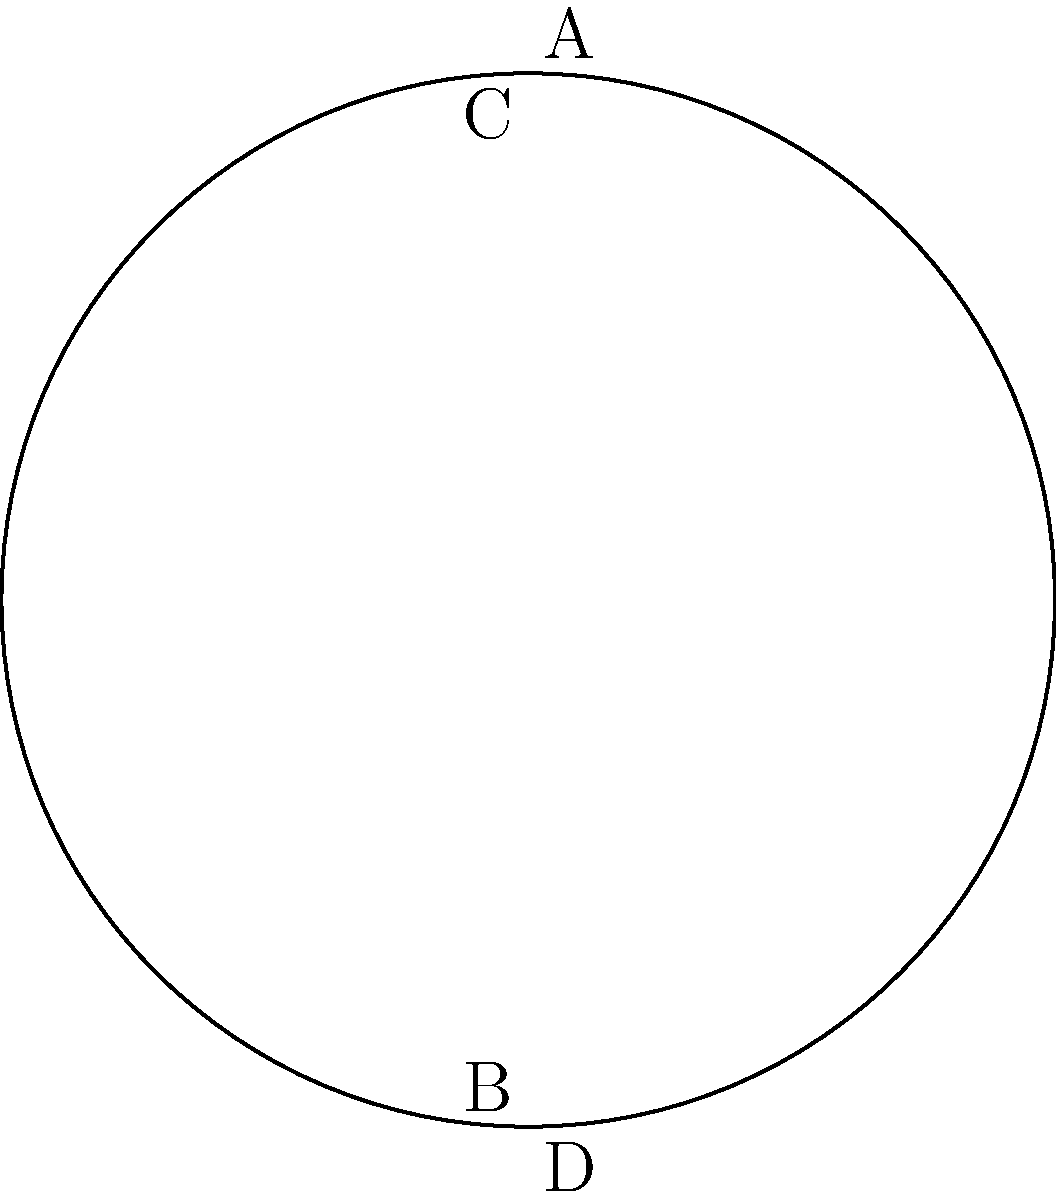In a circular stadium during an emergency evacuation, crowd flow is modeled using non-Euclidean geometry. The stadium is divided into four equal sectors (A, B, C, D) as shown in the diagram. If the crowd density in each sector is proportional to the sector's arc length, and the total crowd in the stadium is 12,000 people, how many people are in sector A? To solve this problem, we'll use concepts from non-Euclidean geometry and circular symmetry:

1. The stadium is divided into four equal sectors, each spanning a 90-degree arc.

2. In non-Euclidean geometry on a sphere (which approximates the curved space of the stadium), the arc length is proportional to the angle it subtends at the center.

3. Since all sectors have equal central angles (90 degrees), they all have equal arc lengths.

4. The crowd density is proportional to the arc length, so each sector will have an equal number of people.

5. To find the number of people in sector A:
   - Total people in the stadium = 12,000
   - Number of equal sectors = 4
   - People in each sector = Total people ÷ Number of sectors
   - People in sector A = $12,000 \div 4 = 3,000$

Therefore, there are 3,000 people in sector A.
Answer: 3,000 people 